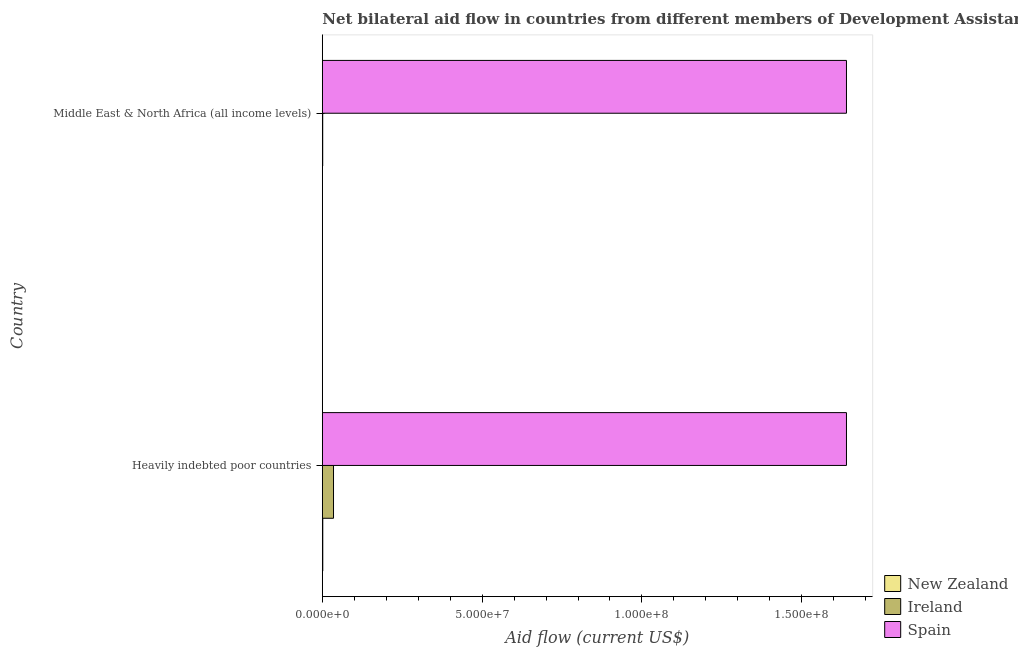How many different coloured bars are there?
Give a very brief answer. 3. How many groups of bars are there?
Provide a succinct answer. 2. Are the number of bars per tick equal to the number of legend labels?
Give a very brief answer. Yes. Are the number of bars on each tick of the Y-axis equal?
Your answer should be very brief. Yes. How many bars are there on the 1st tick from the top?
Ensure brevity in your answer.  3. What is the label of the 2nd group of bars from the top?
Ensure brevity in your answer.  Heavily indebted poor countries. What is the amount of aid provided by new zealand in Middle East & North Africa (all income levels)?
Provide a succinct answer. 10000. Across all countries, what is the maximum amount of aid provided by spain?
Your response must be concise. 1.64e+08. Across all countries, what is the minimum amount of aid provided by ireland?
Provide a short and direct response. 1.20e+05. In which country was the amount of aid provided by spain maximum?
Make the answer very short. Heavily indebted poor countries. In which country was the amount of aid provided by new zealand minimum?
Offer a very short reply. Middle East & North Africa (all income levels). What is the total amount of aid provided by new zealand in the graph?
Provide a succinct answer. 1.50e+05. What is the difference between the amount of aid provided by new zealand in Heavily indebted poor countries and that in Middle East & North Africa (all income levels)?
Ensure brevity in your answer.  1.30e+05. What is the difference between the amount of aid provided by new zealand in Heavily indebted poor countries and the amount of aid provided by ireland in Middle East & North Africa (all income levels)?
Your answer should be very brief. 2.00e+04. What is the average amount of aid provided by new zealand per country?
Offer a terse response. 7.50e+04. What is the difference between the amount of aid provided by spain and amount of aid provided by ireland in Middle East & North Africa (all income levels)?
Offer a very short reply. 1.64e+08. What does the 3rd bar from the top in Heavily indebted poor countries represents?
Your response must be concise. New Zealand. Are all the bars in the graph horizontal?
Provide a short and direct response. Yes. What is the difference between two consecutive major ticks on the X-axis?
Your answer should be very brief. 5.00e+07. Are the values on the major ticks of X-axis written in scientific E-notation?
Offer a terse response. Yes. Does the graph contain grids?
Keep it short and to the point. No. How many legend labels are there?
Offer a terse response. 3. How are the legend labels stacked?
Give a very brief answer. Vertical. What is the title of the graph?
Ensure brevity in your answer.  Net bilateral aid flow in countries from different members of Development Assistance Committee. Does "Consumption Tax" appear as one of the legend labels in the graph?
Your answer should be compact. No. What is the label or title of the Y-axis?
Make the answer very short. Country. What is the Aid flow (current US$) in Ireland in Heavily indebted poor countries?
Make the answer very short. 3.50e+06. What is the Aid flow (current US$) in Spain in Heavily indebted poor countries?
Make the answer very short. 1.64e+08. What is the Aid flow (current US$) in Spain in Middle East & North Africa (all income levels)?
Make the answer very short. 1.64e+08. Across all countries, what is the maximum Aid flow (current US$) in New Zealand?
Your answer should be very brief. 1.40e+05. Across all countries, what is the maximum Aid flow (current US$) of Ireland?
Offer a terse response. 3.50e+06. Across all countries, what is the maximum Aid flow (current US$) of Spain?
Give a very brief answer. 1.64e+08. Across all countries, what is the minimum Aid flow (current US$) of Spain?
Give a very brief answer. 1.64e+08. What is the total Aid flow (current US$) in New Zealand in the graph?
Your answer should be compact. 1.50e+05. What is the total Aid flow (current US$) in Ireland in the graph?
Your answer should be compact. 3.62e+06. What is the total Aid flow (current US$) in Spain in the graph?
Offer a very short reply. 3.28e+08. What is the difference between the Aid flow (current US$) in Ireland in Heavily indebted poor countries and that in Middle East & North Africa (all income levels)?
Your response must be concise. 3.38e+06. What is the difference between the Aid flow (current US$) in New Zealand in Heavily indebted poor countries and the Aid flow (current US$) in Ireland in Middle East & North Africa (all income levels)?
Make the answer very short. 2.00e+04. What is the difference between the Aid flow (current US$) in New Zealand in Heavily indebted poor countries and the Aid flow (current US$) in Spain in Middle East & North Africa (all income levels)?
Offer a terse response. -1.64e+08. What is the difference between the Aid flow (current US$) of Ireland in Heavily indebted poor countries and the Aid flow (current US$) of Spain in Middle East & North Africa (all income levels)?
Your answer should be very brief. -1.60e+08. What is the average Aid flow (current US$) in New Zealand per country?
Keep it short and to the point. 7.50e+04. What is the average Aid flow (current US$) of Ireland per country?
Your response must be concise. 1.81e+06. What is the average Aid flow (current US$) in Spain per country?
Provide a short and direct response. 1.64e+08. What is the difference between the Aid flow (current US$) in New Zealand and Aid flow (current US$) in Ireland in Heavily indebted poor countries?
Ensure brevity in your answer.  -3.36e+06. What is the difference between the Aid flow (current US$) of New Zealand and Aid flow (current US$) of Spain in Heavily indebted poor countries?
Offer a very short reply. -1.64e+08. What is the difference between the Aid flow (current US$) of Ireland and Aid flow (current US$) of Spain in Heavily indebted poor countries?
Keep it short and to the point. -1.60e+08. What is the difference between the Aid flow (current US$) in New Zealand and Aid flow (current US$) in Spain in Middle East & North Africa (all income levels)?
Offer a terse response. -1.64e+08. What is the difference between the Aid flow (current US$) in Ireland and Aid flow (current US$) in Spain in Middle East & North Africa (all income levels)?
Make the answer very short. -1.64e+08. What is the ratio of the Aid flow (current US$) of New Zealand in Heavily indebted poor countries to that in Middle East & North Africa (all income levels)?
Ensure brevity in your answer.  14. What is the ratio of the Aid flow (current US$) of Ireland in Heavily indebted poor countries to that in Middle East & North Africa (all income levels)?
Your response must be concise. 29.17. What is the difference between the highest and the second highest Aid flow (current US$) of Ireland?
Give a very brief answer. 3.38e+06. What is the difference between the highest and the lowest Aid flow (current US$) in New Zealand?
Give a very brief answer. 1.30e+05. What is the difference between the highest and the lowest Aid flow (current US$) of Ireland?
Give a very brief answer. 3.38e+06. What is the difference between the highest and the lowest Aid flow (current US$) of Spain?
Offer a terse response. 0. 